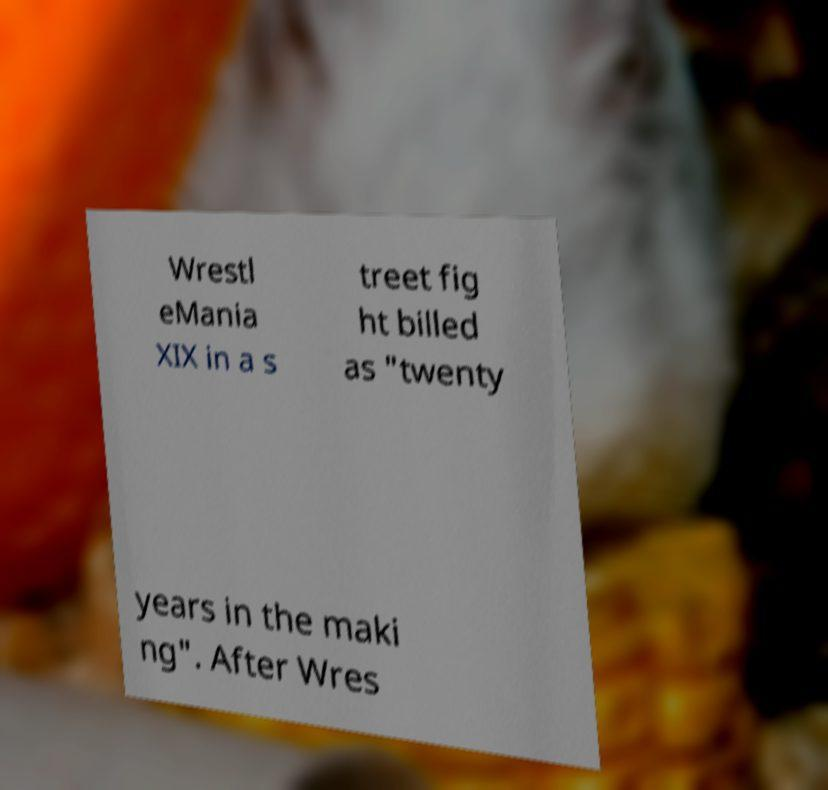What messages or text are displayed in this image? I need them in a readable, typed format. Wrestl eMania XIX in a s treet fig ht billed as "twenty years in the maki ng". After Wres 